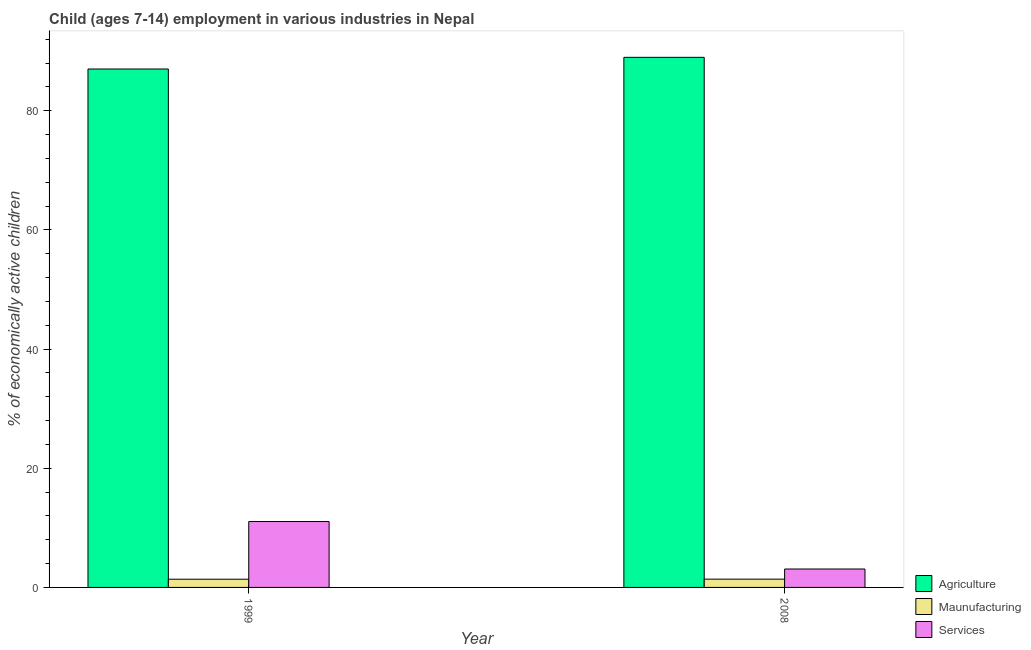How many different coloured bars are there?
Your answer should be compact. 3. What is the percentage of economically active children in services in 2008?
Make the answer very short. 3.09. Across all years, what is the maximum percentage of economically active children in agriculture?
Your answer should be very brief. 88.97. Across all years, what is the minimum percentage of economically active children in agriculture?
Your answer should be very brief. 87.01. In which year was the percentage of economically active children in agriculture minimum?
Provide a short and direct response. 1999. What is the total percentage of economically active children in services in the graph?
Provide a short and direct response. 14.15. What is the difference between the percentage of economically active children in services in 1999 and that in 2008?
Give a very brief answer. 7.97. What is the difference between the percentage of economically active children in agriculture in 1999 and the percentage of economically active children in services in 2008?
Your answer should be very brief. -1.96. What is the average percentage of economically active children in agriculture per year?
Provide a short and direct response. 87.99. In the year 1999, what is the difference between the percentage of economically active children in services and percentage of economically active children in agriculture?
Make the answer very short. 0. What is the ratio of the percentage of economically active children in services in 1999 to that in 2008?
Keep it short and to the point. 3.58. Is the percentage of economically active children in manufacturing in 1999 less than that in 2008?
Offer a terse response. Yes. In how many years, is the percentage of economically active children in agriculture greater than the average percentage of economically active children in agriculture taken over all years?
Your answer should be compact. 1. What does the 3rd bar from the left in 1999 represents?
Provide a short and direct response. Services. What does the 2nd bar from the right in 2008 represents?
Ensure brevity in your answer.  Maunufacturing. Is it the case that in every year, the sum of the percentage of economically active children in agriculture and percentage of economically active children in manufacturing is greater than the percentage of economically active children in services?
Your response must be concise. Yes. Are all the bars in the graph horizontal?
Provide a succinct answer. No. How many years are there in the graph?
Your answer should be very brief. 2. What is the difference between two consecutive major ticks on the Y-axis?
Offer a very short reply. 20. Are the values on the major ticks of Y-axis written in scientific E-notation?
Provide a short and direct response. No. How many legend labels are there?
Provide a succinct answer. 3. How are the legend labels stacked?
Your answer should be compact. Vertical. What is the title of the graph?
Keep it short and to the point. Child (ages 7-14) employment in various industries in Nepal. What is the label or title of the X-axis?
Make the answer very short. Year. What is the label or title of the Y-axis?
Offer a very short reply. % of economically active children. What is the % of economically active children of Agriculture in 1999?
Make the answer very short. 87.01. What is the % of economically active children of Maunufacturing in 1999?
Make the answer very short. 1.38. What is the % of economically active children of Services in 1999?
Ensure brevity in your answer.  11.06. What is the % of economically active children in Agriculture in 2008?
Your answer should be compact. 88.97. What is the % of economically active children of Maunufacturing in 2008?
Keep it short and to the point. 1.39. What is the % of economically active children of Services in 2008?
Your answer should be very brief. 3.09. Across all years, what is the maximum % of economically active children in Agriculture?
Your response must be concise. 88.97. Across all years, what is the maximum % of economically active children of Maunufacturing?
Offer a terse response. 1.39. Across all years, what is the maximum % of economically active children in Services?
Provide a succinct answer. 11.06. Across all years, what is the minimum % of economically active children in Agriculture?
Offer a very short reply. 87.01. Across all years, what is the minimum % of economically active children in Maunufacturing?
Offer a terse response. 1.38. Across all years, what is the minimum % of economically active children of Services?
Your response must be concise. 3.09. What is the total % of economically active children of Agriculture in the graph?
Offer a very short reply. 175.98. What is the total % of economically active children in Maunufacturing in the graph?
Provide a short and direct response. 2.77. What is the total % of economically active children of Services in the graph?
Make the answer very short. 14.15. What is the difference between the % of economically active children of Agriculture in 1999 and that in 2008?
Make the answer very short. -1.96. What is the difference between the % of economically active children in Maunufacturing in 1999 and that in 2008?
Your answer should be very brief. -0.01. What is the difference between the % of economically active children in Services in 1999 and that in 2008?
Offer a terse response. 7.97. What is the difference between the % of economically active children in Agriculture in 1999 and the % of economically active children in Maunufacturing in 2008?
Your answer should be very brief. 85.62. What is the difference between the % of economically active children of Agriculture in 1999 and the % of economically active children of Services in 2008?
Your answer should be compact. 83.92. What is the difference between the % of economically active children in Maunufacturing in 1999 and the % of economically active children in Services in 2008?
Your answer should be very brief. -1.71. What is the average % of economically active children in Agriculture per year?
Make the answer very short. 87.99. What is the average % of economically active children of Maunufacturing per year?
Make the answer very short. 1.39. What is the average % of economically active children in Services per year?
Provide a succinct answer. 7.08. In the year 1999, what is the difference between the % of economically active children of Agriculture and % of economically active children of Maunufacturing?
Give a very brief answer. 85.63. In the year 1999, what is the difference between the % of economically active children of Agriculture and % of economically active children of Services?
Your answer should be very brief. 75.95. In the year 1999, what is the difference between the % of economically active children of Maunufacturing and % of economically active children of Services?
Your response must be concise. -9.68. In the year 2008, what is the difference between the % of economically active children of Agriculture and % of economically active children of Maunufacturing?
Your answer should be compact. 87.58. In the year 2008, what is the difference between the % of economically active children of Agriculture and % of economically active children of Services?
Your response must be concise. 85.88. In the year 2008, what is the difference between the % of economically active children in Maunufacturing and % of economically active children in Services?
Offer a very short reply. -1.7. What is the ratio of the % of economically active children of Services in 1999 to that in 2008?
Keep it short and to the point. 3.58. What is the difference between the highest and the second highest % of economically active children in Agriculture?
Make the answer very short. 1.96. What is the difference between the highest and the second highest % of economically active children of Maunufacturing?
Keep it short and to the point. 0.01. What is the difference between the highest and the second highest % of economically active children of Services?
Provide a short and direct response. 7.97. What is the difference between the highest and the lowest % of economically active children in Agriculture?
Give a very brief answer. 1.96. What is the difference between the highest and the lowest % of economically active children in Services?
Make the answer very short. 7.97. 